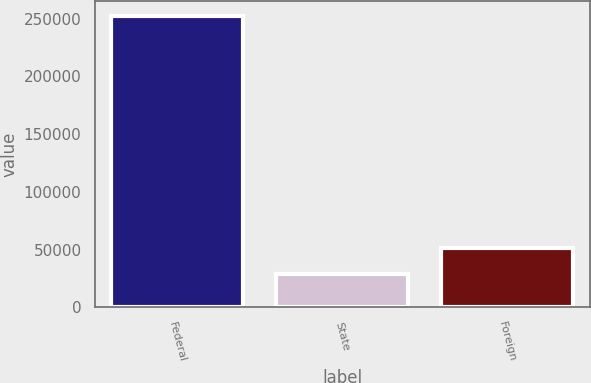Convert chart to OTSL. <chart><loc_0><loc_0><loc_500><loc_500><bar_chart><fcel>Federal<fcel>State<fcel>Foreign<nl><fcel>252337<fcel>29288<fcel>51592.9<nl></chart> 